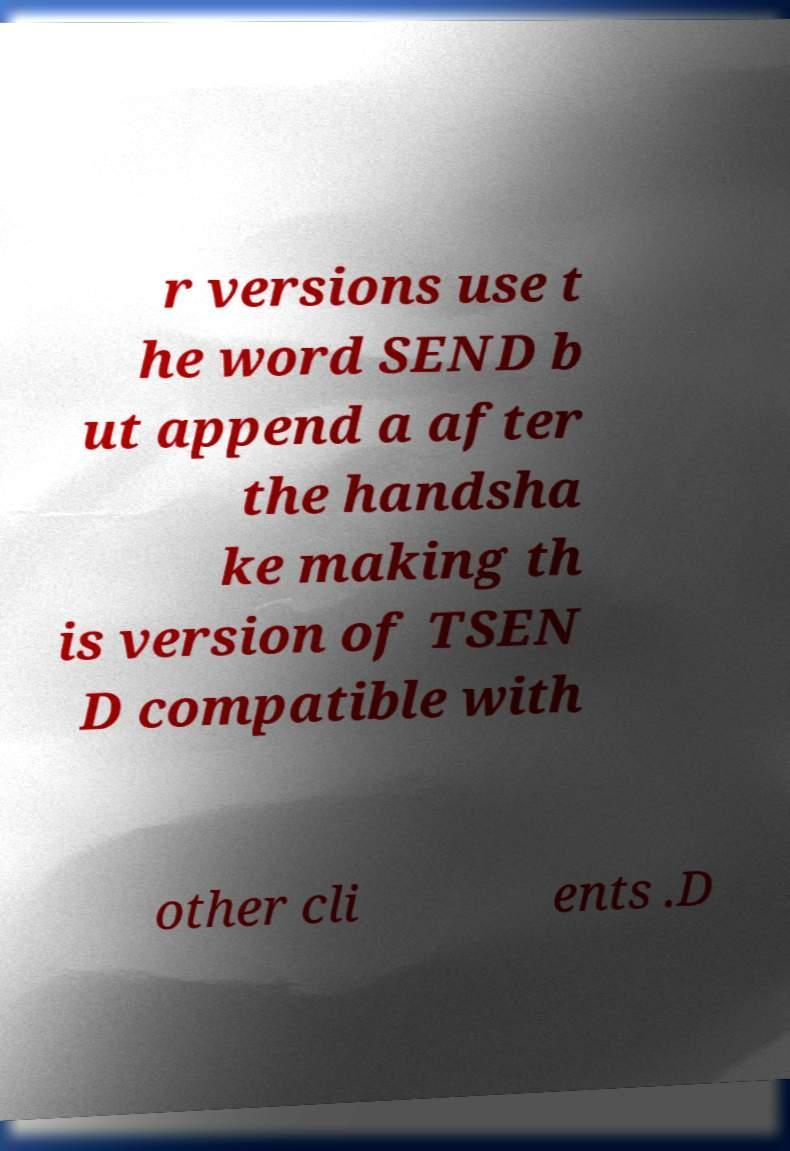Could you assist in decoding the text presented in this image and type it out clearly? r versions use t he word SEND b ut append a after the handsha ke making th is version of TSEN D compatible with other cli ents .D 